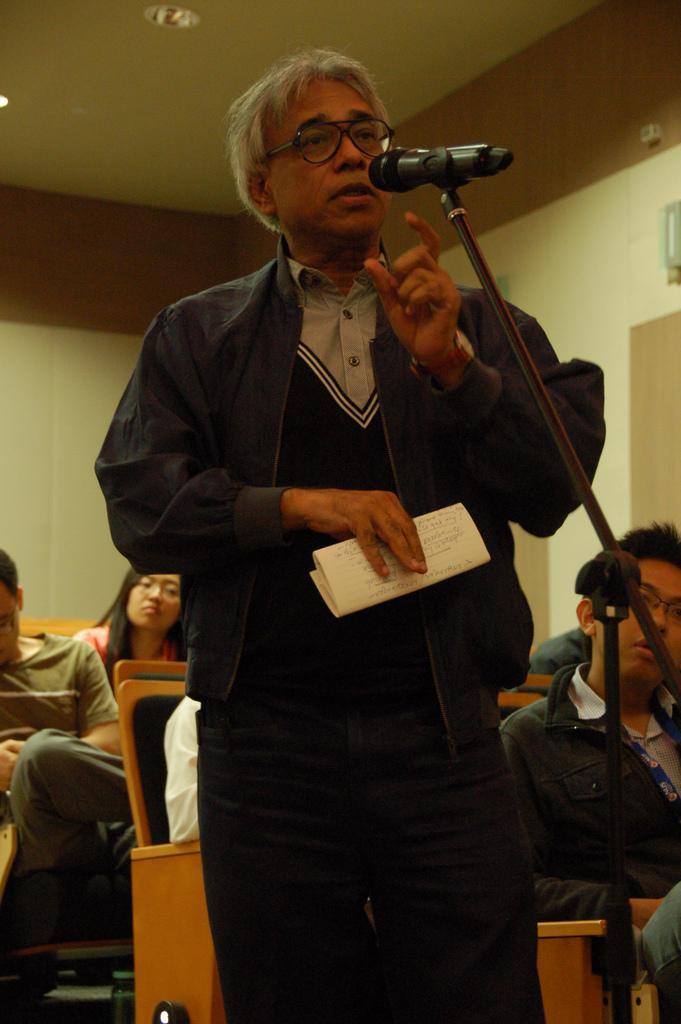In one or two sentences, can you explain what this image depicts? In this picture there is a man who is standing in the center of the image and there is a mic in front of him and there are other people those who are sitting on the chairs in the background area of the image. 